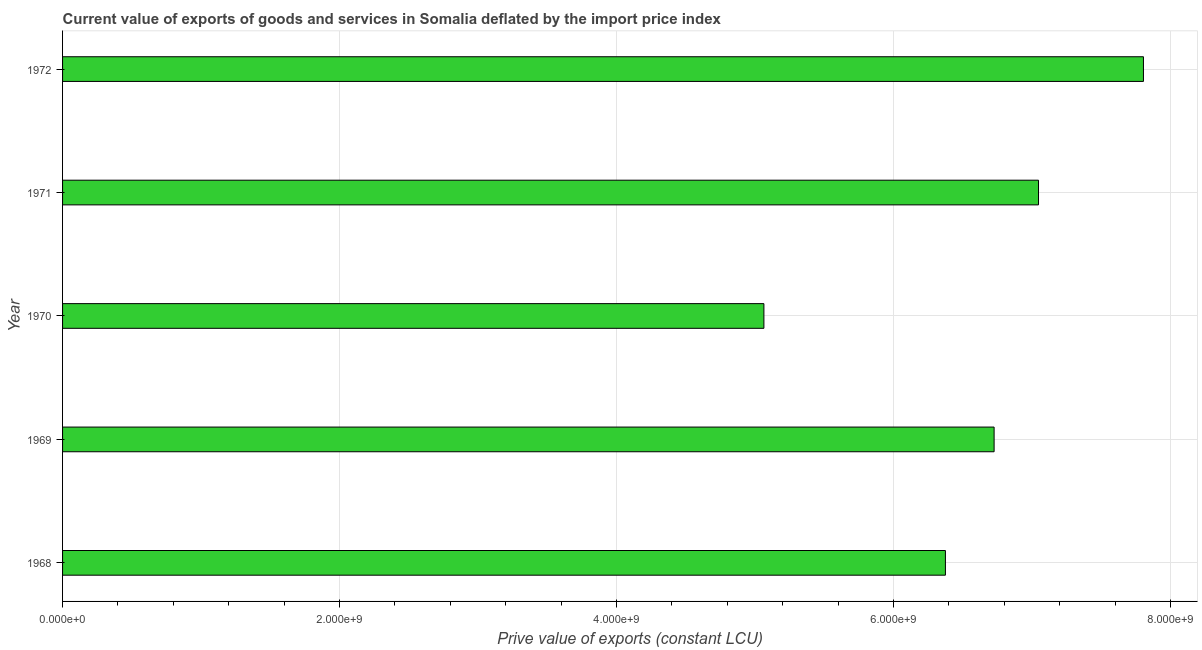Does the graph contain any zero values?
Provide a short and direct response. No. Does the graph contain grids?
Provide a succinct answer. Yes. What is the title of the graph?
Ensure brevity in your answer.  Current value of exports of goods and services in Somalia deflated by the import price index. What is the label or title of the X-axis?
Make the answer very short. Prive value of exports (constant LCU). What is the price value of exports in 1969?
Your answer should be compact. 6.73e+09. Across all years, what is the maximum price value of exports?
Provide a short and direct response. 7.80e+09. Across all years, what is the minimum price value of exports?
Your response must be concise. 5.06e+09. In which year was the price value of exports maximum?
Give a very brief answer. 1972. What is the sum of the price value of exports?
Your answer should be compact. 3.30e+1. What is the difference between the price value of exports in 1968 and 1969?
Your response must be concise. -3.52e+08. What is the average price value of exports per year?
Provide a succinct answer. 6.60e+09. What is the median price value of exports?
Ensure brevity in your answer.  6.73e+09. What is the ratio of the price value of exports in 1969 to that in 1971?
Give a very brief answer. 0.95. Is the difference between the price value of exports in 1968 and 1970 greater than the difference between any two years?
Ensure brevity in your answer.  No. What is the difference between the highest and the second highest price value of exports?
Ensure brevity in your answer.  7.58e+08. What is the difference between the highest and the lowest price value of exports?
Offer a very short reply. 2.74e+09. How many bars are there?
Offer a very short reply. 5. Are all the bars in the graph horizontal?
Your answer should be very brief. Yes. What is the difference between two consecutive major ticks on the X-axis?
Ensure brevity in your answer.  2.00e+09. Are the values on the major ticks of X-axis written in scientific E-notation?
Provide a succinct answer. Yes. What is the Prive value of exports (constant LCU) of 1968?
Give a very brief answer. 6.37e+09. What is the Prive value of exports (constant LCU) in 1969?
Make the answer very short. 6.73e+09. What is the Prive value of exports (constant LCU) in 1970?
Your answer should be compact. 5.06e+09. What is the Prive value of exports (constant LCU) in 1971?
Offer a very short reply. 7.05e+09. What is the Prive value of exports (constant LCU) in 1972?
Ensure brevity in your answer.  7.80e+09. What is the difference between the Prive value of exports (constant LCU) in 1968 and 1969?
Your answer should be compact. -3.52e+08. What is the difference between the Prive value of exports (constant LCU) in 1968 and 1970?
Provide a succinct answer. 1.31e+09. What is the difference between the Prive value of exports (constant LCU) in 1968 and 1971?
Make the answer very short. -6.72e+08. What is the difference between the Prive value of exports (constant LCU) in 1968 and 1972?
Your answer should be very brief. -1.43e+09. What is the difference between the Prive value of exports (constant LCU) in 1969 and 1970?
Provide a succinct answer. 1.66e+09. What is the difference between the Prive value of exports (constant LCU) in 1969 and 1971?
Keep it short and to the point. -3.21e+08. What is the difference between the Prive value of exports (constant LCU) in 1969 and 1972?
Your answer should be very brief. -1.08e+09. What is the difference between the Prive value of exports (constant LCU) in 1970 and 1971?
Make the answer very short. -1.98e+09. What is the difference between the Prive value of exports (constant LCU) in 1970 and 1972?
Provide a short and direct response. -2.74e+09. What is the difference between the Prive value of exports (constant LCU) in 1971 and 1972?
Make the answer very short. -7.58e+08. What is the ratio of the Prive value of exports (constant LCU) in 1968 to that in 1969?
Your answer should be compact. 0.95. What is the ratio of the Prive value of exports (constant LCU) in 1968 to that in 1970?
Provide a short and direct response. 1.26. What is the ratio of the Prive value of exports (constant LCU) in 1968 to that in 1971?
Keep it short and to the point. 0.91. What is the ratio of the Prive value of exports (constant LCU) in 1968 to that in 1972?
Make the answer very short. 0.82. What is the ratio of the Prive value of exports (constant LCU) in 1969 to that in 1970?
Your answer should be compact. 1.33. What is the ratio of the Prive value of exports (constant LCU) in 1969 to that in 1971?
Ensure brevity in your answer.  0.95. What is the ratio of the Prive value of exports (constant LCU) in 1969 to that in 1972?
Your response must be concise. 0.86. What is the ratio of the Prive value of exports (constant LCU) in 1970 to that in 1971?
Provide a succinct answer. 0.72. What is the ratio of the Prive value of exports (constant LCU) in 1970 to that in 1972?
Give a very brief answer. 0.65. What is the ratio of the Prive value of exports (constant LCU) in 1971 to that in 1972?
Provide a short and direct response. 0.9. 